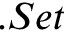Convert formula to latex. <formula><loc_0><loc_0><loc_500><loc_500>. S e t</formula> 